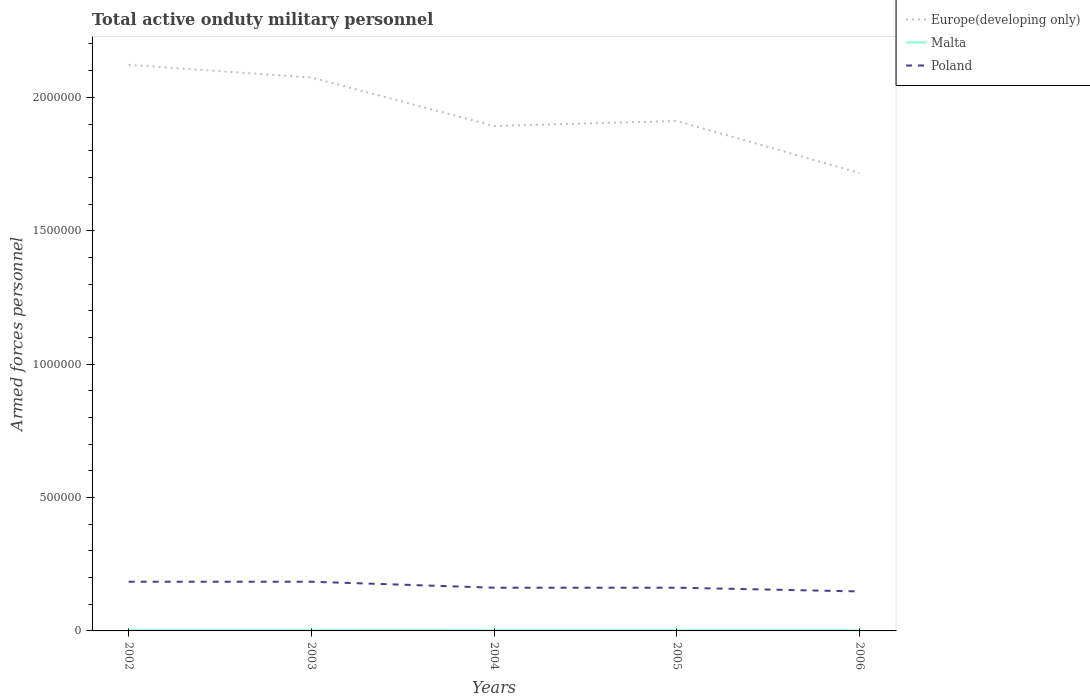How many different coloured lines are there?
Provide a short and direct response. 3. Across all years, what is the maximum number of armed forces personnel in Europe(developing only)?
Your answer should be compact. 1.72e+06. In which year was the number of armed forces personnel in Europe(developing only) maximum?
Keep it short and to the point. 2006. What is the total number of armed forces personnel in Malta in the graph?
Provide a short and direct response. 0. What is the difference between the highest and the second highest number of armed forces personnel in Poland?
Provide a short and direct response. 3.64e+04. Is the number of armed forces personnel in Malta strictly greater than the number of armed forces personnel in Poland over the years?
Provide a succinct answer. Yes. How many lines are there?
Provide a succinct answer. 3. What is the difference between two consecutive major ticks on the Y-axis?
Offer a very short reply. 5.00e+05. Are the values on the major ticks of Y-axis written in scientific E-notation?
Ensure brevity in your answer.  No. Does the graph contain any zero values?
Offer a very short reply. No. Where does the legend appear in the graph?
Offer a terse response. Top right. How many legend labels are there?
Ensure brevity in your answer.  3. How are the legend labels stacked?
Your answer should be very brief. Vertical. What is the title of the graph?
Make the answer very short. Total active onduty military personnel. Does "World" appear as one of the legend labels in the graph?
Give a very brief answer. No. What is the label or title of the X-axis?
Ensure brevity in your answer.  Years. What is the label or title of the Y-axis?
Offer a very short reply. Armed forces personnel. What is the Armed forces personnel of Europe(developing only) in 2002?
Offer a very short reply. 2.12e+06. What is the Armed forces personnel of Malta in 2002?
Ensure brevity in your answer.  2100. What is the Armed forces personnel of Poland in 2002?
Give a very brief answer. 1.84e+05. What is the Armed forces personnel of Europe(developing only) in 2003?
Ensure brevity in your answer.  2.07e+06. What is the Armed forces personnel in Malta in 2003?
Make the answer very short. 2100. What is the Armed forces personnel of Poland in 2003?
Offer a terse response. 1.84e+05. What is the Armed forces personnel in Europe(developing only) in 2004?
Keep it short and to the point. 1.89e+06. What is the Armed forces personnel in Poland in 2004?
Make the answer very short. 1.62e+05. What is the Armed forces personnel in Europe(developing only) in 2005?
Offer a very short reply. 1.91e+06. What is the Armed forces personnel of Malta in 2005?
Ensure brevity in your answer.  2000. What is the Armed forces personnel in Poland in 2005?
Provide a succinct answer. 1.62e+05. What is the Armed forces personnel of Europe(developing only) in 2006?
Provide a short and direct response. 1.72e+06. What is the Armed forces personnel in Malta in 2006?
Ensure brevity in your answer.  2000. What is the Armed forces personnel in Poland in 2006?
Your answer should be very brief. 1.48e+05. Across all years, what is the maximum Armed forces personnel of Europe(developing only)?
Give a very brief answer. 2.12e+06. Across all years, what is the maximum Armed forces personnel in Malta?
Keep it short and to the point. 2100. Across all years, what is the maximum Armed forces personnel of Poland?
Provide a succinct answer. 1.84e+05. Across all years, what is the minimum Armed forces personnel in Europe(developing only)?
Offer a very short reply. 1.72e+06. Across all years, what is the minimum Armed forces personnel in Malta?
Make the answer very short. 2000. Across all years, what is the minimum Armed forces personnel in Poland?
Give a very brief answer. 1.48e+05. What is the total Armed forces personnel of Europe(developing only) in the graph?
Your response must be concise. 9.72e+06. What is the total Armed forces personnel of Malta in the graph?
Your answer should be compact. 1.02e+04. What is the total Armed forces personnel of Poland in the graph?
Offer a terse response. 8.41e+05. What is the difference between the Armed forces personnel of Europe(developing only) in 2002 and that in 2003?
Ensure brevity in your answer.  4.75e+04. What is the difference between the Armed forces personnel in Europe(developing only) in 2002 and that in 2004?
Provide a short and direct response. 2.29e+05. What is the difference between the Armed forces personnel of Poland in 2002 and that in 2004?
Your answer should be compact. 2.24e+04. What is the difference between the Armed forces personnel in Europe(developing only) in 2002 and that in 2005?
Make the answer very short. 2.10e+05. What is the difference between the Armed forces personnel in Poland in 2002 and that in 2005?
Your answer should be very brief. 2.24e+04. What is the difference between the Armed forces personnel in Europe(developing only) in 2002 and that in 2006?
Your answer should be very brief. 4.05e+05. What is the difference between the Armed forces personnel in Poland in 2002 and that in 2006?
Ensure brevity in your answer.  3.64e+04. What is the difference between the Armed forces personnel in Europe(developing only) in 2003 and that in 2004?
Keep it short and to the point. 1.82e+05. What is the difference between the Armed forces personnel in Poland in 2003 and that in 2004?
Provide a short and direct response. 2.24e+04. What is the difference between the Armed forces personnel of Europe(developing only) in 2003 and that in 2005?
Ensure brevity in your answer.  1.63e+05. What is the difference between the Armed forces personnel of Malta in 2003 and that in 2005?
Provide a succinct answer. 100. What is the difference between the Armed forces personnel in Poland in 2003 and that in 2005?
Your answer should be very brief. 2.24e+04. What is the difference between the Armed forces personnel in Europe(developing only) in 2003 and that in 2006?
Your answer should be compact. 3.58e+05. What is the difference between the Armed forces personnel of Poland in 2003 and that in 2006?
Offer a terse response. 3.64e+04. What is the difference between the Armed forces personnel in Europe(developing only) in 2004 and that in 2005?
Give a very brief answer. -1.90e+04. What is the difference between the Armed forces personnel of Europe(developing only) in 2004 and that in 2006?
Give a very brief answer. 1.76e+05. What is the difference between the Armed forces personnel of Poland in 2004 and that in 2006?
Give a very brief answer. 1.40e+04. What is the difference between the Armed forces personnel in Europe(developing only) in 2005 and that in 2006?
Offer a terse response. 1.95e+05. What is the difference between the Armed forces personnel of Poland in 2005 and that in 2006?
Your response must be concise. 1.40e+04. What is the difference between the Armed forces personnel in Europe(developing only) in 2002 and the Armed forces personnel in Malta in 2003?
Your response must be concise. 2.12e+06. What is the difference between the Armed forces personnel of Europe(developing only) in 2002 and the Armed forces personnel of Poland in 2003?
Ensure brevity in your answer.  1.94e+06. What is the difference between the Armed forces personnel in Malta in 2002 and the Armed forces personnel in Poland in 2003?
Your response must be concise. -1.82e+05. What is the difference between the Armed forces personnel in Europe(developing only) in 2002 and the Armed forces personnel in Malta in 2004?
Your response must be concise. 2.12e+06. What is the difference between the Armed forces personnel of Europe(developing only) in 2002 and the Armed forces personnel of Poland in 2004?
Keep it short and to the point. 1.96e+06. What is the difference between the Armed forces personnel in Malta in 2002 and the Armed forces personnel in Poland in 2004?
Keep it short and to the point. -1.60e+05. What is the difference between the Armed forces personnel in Europe(developing only) in 2002 and the Armed forces personnel in Malta in 2005?
Your answer should be very brief. 2.12e+06. What is the difference between the Armed forces personnel in Europe(developing only) in 2002 and the Armed forces personnel in Poland in 2005?
Ensure brevity in your answer.  1.96e+06. What is the difference between the Armed forces personnel in Malta in 2002 and the Armed forces personnel in Poland in 2005?
Ensure brevity in your answer.  -1.60e+05. What is the difference between the Armed forces personnel of Europe(developing only) in 2002 and the Armed forces personnel of Malta in 2006?
Give a very brief answer. 2.12e+06. What is the difference between the Armed forces personnel of Europe(developing only) in 2002 and the Armed forces personnel of Poland in 2006?
Offer a very short reply. 1.97e+06. What is the difference between the Armed forces personnel in Malta in 2002 and the Armed forces personnel in Poland in 2006?
Ensure brevity in your answer.  -1.46e+05. What is the difference between the Armed forces personnel in Europe(developing only) in 2003 and the Armed forces personnel in Malta in 2004?
Give a very brief answer. 2.07e+06. What is the difference between the Armed forces personnel of Europe(developing only) in 2003 and the Armed forces personnel of Poland in 2004?
Make the answer very short. 1.91e+06. What is the difference between the Armed forces personnel of Malta in 2003 and the Armed forces personnel of Poland in 2004?
Ensure brevity in your answer.  -1.60e+05. What is the difference between the Armed forces personnel of Europe(developing only) in 2003 and the Armed forces personnel of Malta in 2005?
Your answer should be very brief. 2.07e+06. What is the difference between the Armed forces personnel of Europe(developing only) in 2003 and the Armed forces personnel of Poland in 2005?
Your response must be concise. 1.91e+06. What is the difference between the Armed forces personnel in Malta in 2003 and the Armed forces personnel in Poland in 2005?
Provide a succinct answer. -1.60e+05. What is the difference between the Armed forces personnel of Europe(developing only) in 2003 and the Armed forces personnel of Malta in 2006?
Offer a very short reply. 2.07e+06. What is the difference between the Armed forces personnel in Europe(developing only) in 2003 and the Armed forces personnel in Poland in 2006?
Your response must be concise. 1.93e+06. What is the difference between the Armed forces personnel of Malta in 2003 and the Armed forces personnel of Poland in 2006?
Your response must be concise. -1.46e+05. What is the difference between the Armed forces personnel of Europe(developing only) in 2004 and the Armed forces personnel of Malta in 2005?
Your answer should be very brief. 1.89e+06. What is the difference between the Armed forces personnel in Europe(developing only) in 2004 and the Armed forces personnel in Poland in 2005?
Offer a terse response. 1.73e+06. What is the difference between the Armed forces personnel of Malta in 2004 and the Armed forces personnel of Poland in 2005?
Offer a terse response. -1.60e+05. What is the difference between the Armed forces personnel of Europe(developing only) in 2004 and the Armed forces personnel of Malta in 2006?
Ensure brevity in your answer.  1.89e+06. What is the difference between the Armed forces personnel of Europe(developing only) in 2004 and the Armed forces personnel of Poland in 2006?
Give a very brief answer. 1.74e+06. What is the difference between the Armed forces personnel in Malta in 2004 and the Armed forces personnel in Poland in 2006?
Provide a short and direct response. -1.46e+05. What is the difference between the Armed forces personnel in Europe(developing only) in 2005 and the Armed forces personnel in Malta in 2006?
Make the answer very short. 1.91e+06. What is the difference between the Armed forces personnel in Europe(developing only) in 2005 and the Armed forces personnel in Poland in 2006?
Ensure brevity in your answer.  1.76e+06. What is the difference between the Armed forces personnel in Malta in 2005 and the Armed forces personnel in Poland in 2006?
Your response must be concise. -1.46e+05. What is the average Armed forces personnel in Europe(developing only) per year?
Make the answer very short. 1.94e+06. What is the average Armed forces personnel in Malta per year?
Give a very brief answer. 2040. What is the average Armed forces personnel in Poland per year?
Give a very brief answer. 1.68e+05. In the year 2002, what is the difference between the Armed forces personnel in Europe(developing only) and Armed forces personnel in Malta?
Your response must be concise. 2.12e+06. In the year 2002, what is the difference between the Armed forces personnel in Europe(developing only) and Armed forces personnel in Poland?
Offer a terse response. 1.94e+06. In the year 2002, what is the difference between the Armed forces personnel of Malta and Armed forces personnel of Poland?
Make the answer very short. -1.82e+05. In the year 2003, what is the difference between the Armed forces personnel of Europe(developing only) and Armed forces personnel of Malta?
Give a very brief answer. 2.07e+06. In the year 2003, what is the difference between the Armed forces personnel in Europe(developing only) and Armed forces personnel in Poland?
Keep it short and to the point. 1.89e+06. In the year 2003, what is the difference between the Armed forces personnel in Malta and Armed forces personnel in Poland?
Ensure brevity in your answer.  -1.82e+05. In the year 2004, what is the difference between the Armed forces personnel of Europe(developing only) and Armed forces personnel of Malta?
Make the answer very short. 1.89e+06. In the year 2004, what is the difference between the Armed forces personnel of Europe(developing only) and Armed forces personnel of Poland?
Offer a terse response. 1.73e+06. In the year 2004, what is the difference between the Armed forces personnel in Malta and Armed forces personnel in Poland?
Offer a terse response. -1.60e+05. In the year 2005, what is the difference between the Armed forces personnel of Europe(developing only) and Armed forces personnel of Malta?
Offer a terse response. 1.91e+06. In the year 2005, what is the difference between the Armed forces personnel of Europe(developing only) and Armed forces personnel of Poland?
Your answer should be compact. 1.75e+06. In the year 2005, what is the difference between the Armed forces personnel in Malta and Armed forces personnel in Poland?
Give a very brief answer. -1.60e+05. In the year 2006, what is the difference between the Armed forces personnel in Europe(developing only) and Armed forces personnel in Malta?
Make the answer very short. 1.71e+06. In the year 2006, what is the difference between the Armed forces personnel of Europe(developing only) and Armed forces personnel of Poland?
Offer a terse response. 1.57e+06. In the year 2006, what is the difference between the Armed forces personnel of Malta and Armed forces personnel of Poland?
Your answer should be compact. -1.46e+05. What is the ratio of the Armed forces personnel in Europe(developing only) in 2002 to that in 2003?
Give a very brief answer. 1.02. What is the ratio of the Armed forces personnel in Poland in 2002 to that in 2003?
Make the answer very short. 1. What is the ratio of the Armed forces personnel in Europe(developing only) in 2002 to that in 2004?
Keep it short and to the point. 1.12. What is the ratio of the Armed forces personnel of Poland in 2002 to that in 2004?
Your response must be concise. 1.14. What is the ratio of the Armed forces personnel of Europe(developing only) in 2002 to that in 2005?
Your response must be concise. 1.11. What is the ratio of the Armed forces personnel in Malta in 2002 to that in 2005?
Offer a very short reply. 1.05. What is the ratio of the Armed forces personnel of Poland in 2002 to that in 2005?
Keep it short and to the point. 1.14. What is the ratio of the Armed forces personnel in Europe(developing only) in 2002 to that in 2006?
Your answer should be very brief. 1.24. What is the ratio of the Armed forces personnel in Malta in 2002 to that in 2006?
Your answer should be compact. 1.05. What is the ratio of the Armed forces personnel in Poland in 2002 to that in 2006?
Make the answer very short. 1.25. What is the ratio of the Armed forces personnel in Europe(developing only) in 2003 to that in 2004?
Your answer should be compact. 1.1. What is the ratio of the Armed forces personnel of Poland in 2003 to that in 2004?
Your response must be concise. 1.14. What is the ratio of the Armed forces personnel in Europe(developing only) in 2003 to that in 2005?
Your response must be concise. 1.09. What is the ratio of the Armed forces personnel of Malta in 2003 to that in 2005?
Your response must be concise. 1.05. What is the ratio of the Armed forces personnel in Poland in 2003 to that in 2005?
Provide a short and direct response. 1.14. What is the ratio of the Armed forces personnel in Europe(developing only) in 2003 to that in 2006?
Your answer should be compact. 1.21. What is the ratio of the Armed forces personnel in Malta in 2003 to that in 2006?
Offer a terse response. 1.05. What is the ratio of the Armed forces personnel of Poland in 2003 to that in 2006?
Provide a succinct answer. 1.25. What is the ratio of the Armed forces personnel of Europe(developing only) in 2004 to that in 2005?
Give a very brief answer. 0.99. What is the ratio of the Armed forces personnel in Malta in 2004 to that in 2005?
Ensure brevity in your answer.  1. What is the ratio of the Armed forces personnel of Poland in 2004 to that in 2005?
Make the answer very short. 1. What is the ratio of the Armed forces personnel of Europe(developing only) in 2004 to that in 2006?
Make the answer very short. 1.1. What is the ratio of the Armed forces personnel of Malta in 2004 to that in 2006?
Make the answer very short. 1. What is the ratio of the Armed forces personnel in Poland in 2004 to that in 2006?
Ensure brevity in your answer.  1.09. What is the ratio of the Armed forces personnel of Europe(developing only) in 2005 to that in 2006?
Provide a short and direct response. 1.11. What is the ratio of the Armed forces personnel of Poland in 2005 to that in 2006?
Offer a very short reply. 1.09. What is the difference between the highest and the second highest Armed forces personnel of Europe(developing only)?
Your response must be concise. 4.75e+04. What is the difference between the highest and the second highest Armed forces personnel in Malta?
Your answer should be compact. 0. What is the difference between the highest and the second highest Armed forces personnel of Poland?
Keep it short and to the point. 0. What is the difference between the highest and the lowest Armed forces personnel in Europe(developing only)?
Ensure brevity in your answer.  4.05e+05. What is the difference between the highest and the lowest Armed forces personnel of Malta?
Keep it short and to the point. 100. What is the difference between the highest and the lowest Armed forces personnel of Poland?
Provide a succinct answer. 3.64e+04. 